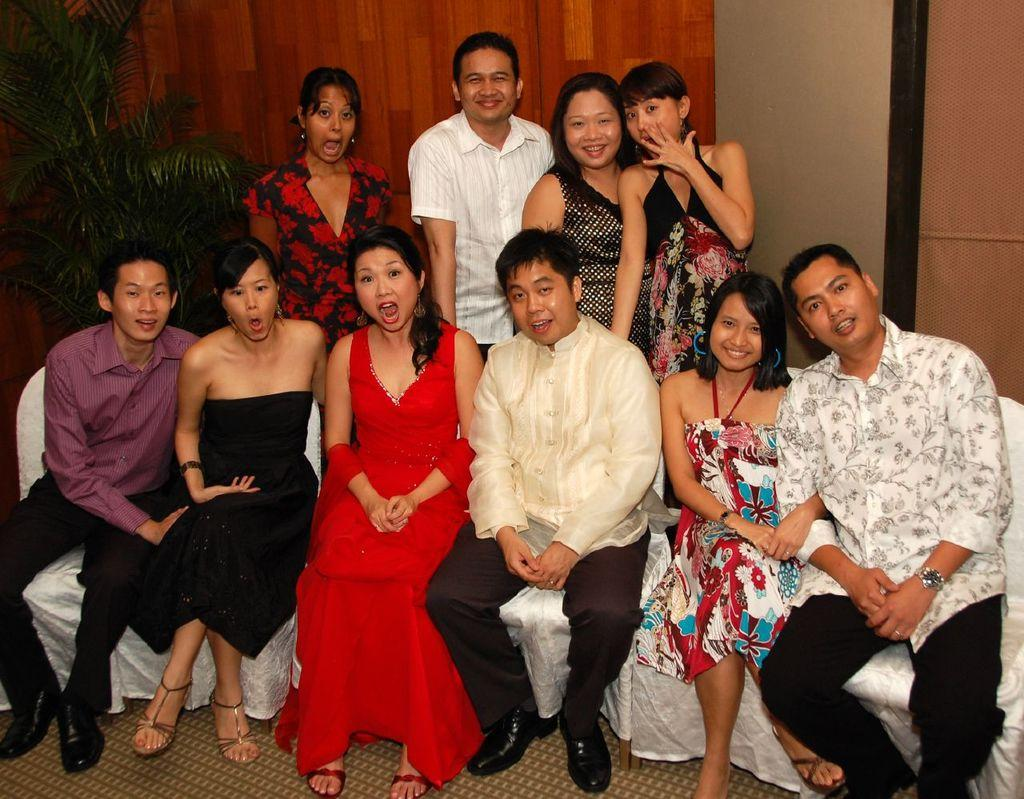How many people are in the image? There is a group of people in the image, but the exact number is not specified. What are the people in the image doing? The people are posing for a photo. What can be seen on the left side of the image? There is a plant on the left side of the image. What is visible in the background of the image? There is a curtain in the background of the image. How many hats can be seen on the people in the image? There is no mention of hats in the image, so we cannot determine the number of hats present. Are there any dinosaurs visible in the image? No, there are no dinosaurs present in the image. 